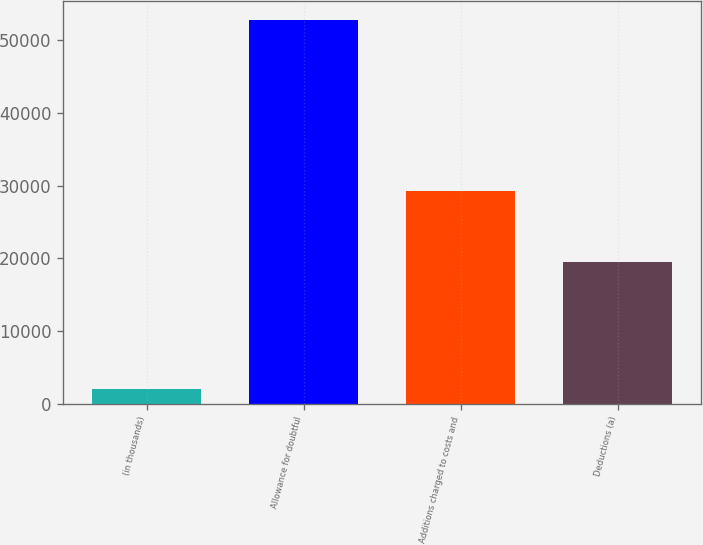<chart> <loc_0><loc_0><loc_500><loc_500><bar_chart><fcel>(in thousands)<fcel>Allowance for doubtful<fcel>Additions charged to costs and<fcel>Deductions (a)<nl><fcel>2017<fcel>52786<fcel>29248<fcel>19490<nl></chart> 